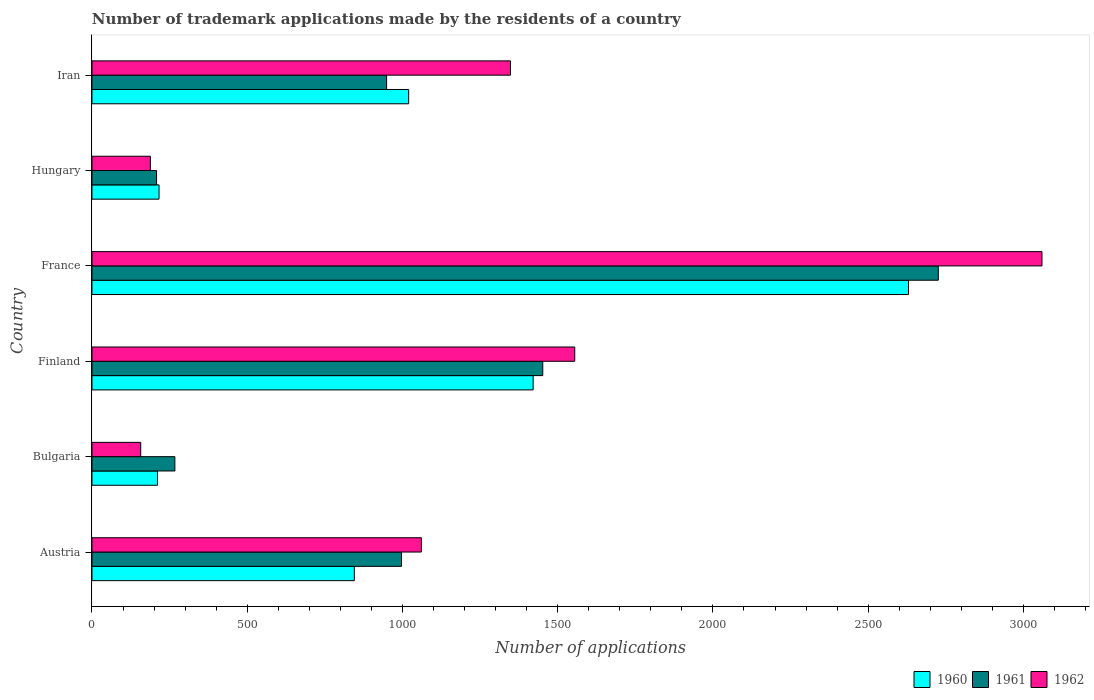How many bars are there on the 2nd tick from the top?
Ensure brevity in your answer.  3. How many bars are there on the 4th tick from the bottom?
Provide a succinct answer. 3. What is the label of the 1st group of bars from the top?
Provide a succinct answer. Iran. In how many cases, is the number of bars for a given country not equal to the number of legend labels?
Give a very brief answer. 0. What is the number of trademark applications made by the residents in 1962 in Iran?
Your answer should be compact. 1348. Across all countries, what is the maximum number of trademark applications made by the residents in 1961?
Provide a succinct answer. 2726. Across all countries, what is the minimum number of trademark applications made by the residents in 1961?
Provide a succinct answer. 208. What is the total number of trademark applications made by the residents in 1960 in the graph?
Offer a very short reply. 6343. What is the difference between the number of trademark applications made by the residents in 1960 in Austria and that in Bulgaria?
Your answer should be compact. 634. What is the difference between the number of trademark applications made by the residents in 1962 in Bulgaria and the number of trademark applications made by the residents in 1960 in Austria?
Offer a very short reply. -688. What is the average number of trademark applications made by the residents in 1962 per country?
Provide a short and direct response. 1228.17. What is the difference between the number of trademark applications made by the residents in 1962 and number of trademark applications made by the residents in 1961 in Finland?
Give a very brief answer. 103. What is the ratio of the number of trademark applications made by the residents in 1962 in Bulgaria to that in Hungary?
Offer a terse response. 0.84. What is the difference between the highest and the second highest number of trademark applications made by the residents in 1961?
Give a very brief answer. 1274. What is the difference between the highest and the lowest number of trademark applications made by the residents in 1961?
Give a very brief answer. 2518. What does the 1st bar from the bottom in Hungary represents?
Offer a very short reply. 1960. Is it the case that in every country, the sum of the number of trademark applications made by the residents in 1960 and number of trademark applications made by the residents in 1961 is greater than the number of trademark applications made by the residents in 1962?
Ensure brevity in your answer.  Yes. What is the difference between two consecutive major ticks on the X-axis?
Keep it short and to the point. 500. Are the values on the major ticks of X-axis written in scientific E-notation?
Your response must be concise. No. Does the graph contain any zero values?
Make the answer very short. No. Does the graph contain grids?
Give a very brief answer. No. How many legend labels are there?
Provide a short and direct response. 3. How are the legend labels stacked?
Make the answer very short. Horizontal. What is the title of the graph?
Ensure brevity in your answer.  Number of trademark applications made by the residents of a country. Does "2006" appear as one of the legend labels in the graph?
Offer a terse response. No. What is the label or title of the X-axis?
Provide a short and direct response. Number of applications. What is the label or title of the Y-axis?
Provide a succinct answer. Country. What is the Number of applications in 1960 in Austria?
Keep it short and to the point. 845. What is the Number of applications in 1961 in Austria?
Your response must be concise. 997. What is the Number of applications in 1962 in Austria?
Give a very brief answer. 1061. What is the Number of applications of 1960 in Bulgaria?
Offer a terse response. 211. What is the Number of applications of 1961 in Bulgaria?
Give a very brief answer. 267. What is the Number of applications in 1962 in Bulgaria?
Your answer should be compact. 157. What is the Number of applications of 1960 in Finland?
Give a very brief answer. 1421. What is the Number of applications in 1961 in Finland?
Your response must be concise. 1452. What is the Number of applications of 1962 in Finland?
Offer a terse response. 1555. What is the Number of applications of 1960 in France?
Your response must be concise. 2630. What is the Number of applications in 1961 in France?
Offer a very short reply. 2726. What is the Number of applications in 1962 in France?
Make the answer very short. 3060. What is the Number of applications in 1960 in Hungary?
Offer a very short reply. 216. What is the Number of applications of 1961 in Hungary?
Provide a succinct answer. 208. What is the Number of applications of 1962 in Hungary?
Your response must be concise. 188. What is the Number of applications in 1960 in Iran?
Ensure brevity in your answer.  1020. What is the Number of applications of 1961 in Iran?
Provide a short and direct response. 949. What is the Number of applications of 1962 in Iran?
Ensure brevity in your answer.  1348. Across all countries, what is the maximum Number of applications in 1960?
Provide a short and direct response. 2630. Across all countries, what is the maximum Number of applications of 1961?
Keep it short and to the point. 2726. Across all countries, what is the maximum Number of applications of 1962?
Provide a short and direct response. 3060. Across all countries, what is the minimum Number of applications of 1960?
Provide a short and direct response. 211. Across all countries, what is the minimum Number of applications in 1961?
Give a very brief answer. 208. Across all countries, what is the minimum Number of applications in 1962?
Provide a short and direct response. 157. What is the total Number of applications in 1960 in the graph?
Your answer should be very brief. 6343. What is the total Number of applications in 1961 in the graph?
Your answer should be very brief. 6599. What is the total Number of applications in 1962 in the graph?
Provide a succinct answer. 7369. What is the difference between the Number of applications of 1960 in Austria and that in Bulgaria?
Your answer should be compact. 634. What is the difference between the Number of applications in 1961 in Austria and that in Bulgaria?
Keep it short and to the point. 730. What is the difference between the Number of applications of 1962 in Austria and that in Bulgaria?
Your response must be concise. 904. What is the difference between the Number of applications in 1960 in Austria and that in Finland?
Ensure brevity in your answer.  -576. What is the difference between the Number of applications of 1961 in Austria and that in Finland?
Make the answer very short. -455. What is the difference between the Number of applications of 1962 in Austria and that in Finland?
Provide a short and direct response. -494. What is the difference between the Number of applications in 1960 in Austria and that in France?
Your answer should be compact. -1785. What is the difference between the Number of applications of 1961 in Austria and that in France?
Ensure brevity in your answer.  -1729. What is the difference between the Number of applications in 1962 in Austria and that in France?
Give a very brief answer. -1999. What is the difference between the Number of applications of 1960 in Austria and that in Hungary?
Offer a terse response. 629. What is the difference between the Number of applications of 1961 in Austria and that in Hungary?
Keep it short and to the point. 789. What is the difference between the Number of applications in 1962 in Austria and that in Hungary?
Your response must be concise. 873. What is the difference between the Number of applications in 1960 in Austria and that in Iran?
Your answer should be compact. -175. What is the difference between the Number of applications in 1961 in Austria and that in Iran?
Keep it short and to the point. 48. What is the difference between the Number of applications in 1962 in Austria and that in Iran?
Your response must be concise. -287. What is the difference between the Number of applications in 1960 in Bulgaria and that in Finland?
Provide a short and direct response. -1210. What is the difference between the Number of applications of 1961 in Bulgaria and that in Finland?
Provide a short and direct response. -1185. What is the difference between the Number of applications of 1962 in Bulgaria and that in Finland?
Make the answer very short. -1398. What is the difference between the Number of applications of 1960 in Bulgaria and that in France?
Provide a short and direct response. -2419. What is the difference between the Number of applications in 1961 in Bulgaria and that in France?
Ensure brevity in your answer.  -2459. What is the difference between the Number of applications in 1962 in Bulgaria and that in France?
Your response must be concise. -2903. What is the difference between the Number of applications of 1960 in Bulgaria and that in Hungary?
Ensure brevity in your answer.  -5. What is the difference between the Number of applications in 1961 in Bulgaria and that in Hungary?
Make the answer very short. 59. What is the difference between the Number of applications in 1962 in Bulgaria and that in Hungary?
Your answer should be very brief. -31. What is the difference between the Number of applications in 1960 in Bulgaria and that in Iran?
Ensure brevity in your answer.  -809. What is the difference between the Number of applications of 1961 in Bulgaria and that in Iran?
Keep it short and to the point. -682. What is the difference between the Number of applications of 1962 in Bulgaria and that in Iran?
Ensure brevity in your answer.  -1191. What is the difference between the Number of applications of 1960 in Finland and that in France?
Keep it short and to the point. -1209. What is the difference between the Number of applications of 1961 in Finland and that in France?
Offer a terse response. -1274. What is the difference between the Number of applications of 1962 in Finland and that in France?
Offer a very short reply. -1505. What is the difference between the Number of applications of 1960 in Finland and that in Hungary?
Your answer should be very brief. 1205. What is the difference between the Number of applications of 1961 in Finland and that in Hungary?
Your response must be concise. 1244. What is the difference between the Number of applications in 1962 in Finland and that in Hungary?
Give a very brief answer. 1367. What is the difference between the Number of applications in 1960 in Finland and that in Iran?
Your answer should be very brief. 401. What is the difference between the Number of applications of 1961 in Finland and that in Iran?
Give a very brief answer. 503. What is the difference between the Number of applications of 1962 in Finland and that in Iran?
Give a very brief answer. 207. What is the difference between the Number of applications in 1960 in France and that in Hungary?
Provide a short and direct response. 2414. What is the difference between the Number of applications of 1961 in France and that in Hungary?
Ensure brevity in your answer.  2518. What is the difference between the Number of applications in 1962 in France and that in Hungary?
Ensure brevity in your answer.  2872. What is the difference between the Number of applications in 1960 in France and that in Iran?
Provide a succinct answer. 1610. What is the difference between the Number of applications of 1961 in France and that in Iran?
Ensure brevity in your answer.  1777. What is the difference between the Number of applications in 1962 in France and that in Iran?
Keep it short and to the point. 1712. What is the difference between the Number of applications in 1960 in Hungary and that in Iran?
Your response must be concise. -804. What is the difference between the Number of applications of 1961 in Hungary and that in Iran?
Give a very brief answer. -741. What is the difference between the Number of applications in 1962 in Hungary and that in Iran?
Give a very brief answer. -1160. What is the difference between the Number of applications of 1960 in Austria and the Number of applications of 1961 in Bulgaria?
Give a very brief answer. 578. What is the difference between the Number of applications in 1960 in Austria and the Number of applications in 1962 in Bulgaria?
Provide a succinct answer. 688. What is the difference between the Number of applications in 1961 in Austria and the Number of applications in 1962 in Bulgaria?
Your answer should be very brief. 840. What is the difference between the Number of applications of 1960 in Austria and the Number of applications of 1961 in Finland?
Keep it short and to the point. -607. What is the difference between the Number of applications in 1960 in Austria and the Number of applications in 1962 in Finland?
Make the answer very short. -710. What is the difference between the Number of applications in 1961 in Austria and the Number of applications in 1962 in Finland?
Offer a terse response. -558. What is the difference between the Number of applications in 1960 in Austria and the Number of applications in 1961 in France?
Your answer should be very brief. -1881. What is the difference between the Number of applications in 1960 in Austria and the Number of applications in 1962 in France?
Make the answer very short. -2215. What is the difference between the Number of applications in 1961 in Austria and the Number of applications in 1962 in France?
Ensure brevity in your answer.  -2063. What is the difference between the Number of applications of 1960 in Austria and the Number of applications of 1961 in Hungary?
Offer a terse response. 637. What is the difference between the Number of applications of 1960 in Austria and the Number of applications of 1962 in Hungary?
Give a very brief answer. 657. What is the difference between the Number of applications in 1961 in Austria and the Number of applications in 1962 in Hungary?
Keep it short and to the point. 809. What is the difference between the Number of applications in 1960 in Austria and the Number of applications in 1961 in Iran?
Provide a succinct answer. -104. What is the difference between the Number of applications of 1960 in Austria and the Number of applications of 1962 in Iran?
Your answer should be compact. -503. What is the difference between the Number of applications of 1961 in Austria and the Number of applications of 1962 in Iran?
Give a very brief answer. -351. What is the difference between the Number of applications of 1960 in Bulgaria and the Number of applications of 1961 in Finland?
Provide a succinct answer. -1241. What is the difference between the Number of applications of 1960 in Bulgaria and the Number of applications of 1962 in Finland?
Your response must be concise. -1344. What is the difference between the Number of applications of 1961 in Bulgaria and the Number of applications of 1962 in Finland?
Offer a very short reply. -1288. What is the difference between the Number of applications in 1960 in Bulgaria and the Number of applications in 1961 in France?
Ensure brevity in your answer.  -2515. What is the difference between the Number of applications of 1960 in Bulgaria and the Number of applications of 1962 in France?
Offer a very short reply. -2849. What is the difference between the Number of applications of 1961 in Bulgaria and the Number of applications of 1962 in France?
Provide a succinct answer. -2793. What is the difference between the Number of applications in 1960 in Bulgaria and the Number of applications in 1961 in Hungary?
Your answer should be compact. 3. What is the difference between the Number of applications in 1960 in Bulgaria and the Number of applications in 1962 in Hungary?
Ensure brevity in your answer.  23. What is the difference between the Number of applications in 1961 in Bulgaria and the Number of applications in 1962 in Hungary?
Your answer should be very brief. 79. What is the difference between the Number of applications of 1960 in Bulgaria and the Number of applications of 1961 in Iran?
Offer a terse response. -738. What is the difference between the Number of applications of 1960 in Bulgaria and the Number of applications of 1962 in Iran?
Provide a short and direct response. -1137. What is the difference between the Number of applications of 1961 in Bulgaria and the Number of applications of 1962 in Iran?
Keep it short and to the point. -1081. What is the difference between the Number of applications of 1960 in Finland and the Number of applications of 1961 in France?
Your answer should be compact. -1305. What is the difference between the Number of applications of 1960 in Finland and the Number of applications of 1962 in France?
Offer a very short reply. -1639. What is the difference between the Number of applications of 1961 in Finland and the Number of applications of 1962 in France?
Provide a succinct answer. -1608. What is the difference between the Number of applications of 1960 in Finland and the Number of applications of 1961 in Hungary?
Your response must be concise. 1213. What is the difference between the Number of applications of 1960 in Finland and the Number of applications of 1962 in Hungary?
Offer a terse response. 1233. What is the difference between the Number of applications in 1961 in Finland and the Number of applications in 1962 in Hungary?
Your answer should be compact. 1264. What is the difference between the Number of applications of 1960 in Finland and the Number of applications of 1961 in Iran?
Offer a terse response. 472. What is the difference between the Number of applications of 1960 in Finland and the Number of applications of 1962 in Iran?
Offer a terse response. 73. What is the difference between the Number of applications in 1961 in Finland and the Number of applications in 1962 in Iran?
Offer a terse response. 104. What is the difference between the Number of applications of 1960 in France and the Number of applications of 1961 in Hungary?
Provide a succinct answer. 2422. What is the difference between the Number of applications in 1960 in France and the Number of applications in 1962 in Hungary?
Keep it short and to the point. 2442. What is the difference between the Number of applications of 1961 in France and the Number of applications of 1962 in Hungary?
Give a very brief answer. 2538. What is the difference between the Number of applications in 1960 in France and the Number of applications in 1961 in Iran?
Provide a succinct answer. 1681. What is the difference between the Number of applications in 1960 in France and the Number of applications in 1962 in Iran?
Your answer should be very brief. 1282. What is the difference between the Number of applications in 1961 in France and the Number of applications in 1962 in Iran?
Make the answer very short. 1378. What is the difference between the Number of applications of 1960 in Hungary and the Number of applications of 1961 in Iran?
Offer a very short reply. -733. What is the difference between the Number of applications of 1960 in Hungary and the Number of applications of 1962 in Iran?
Offer a very short reply. -1132. What is the difference between the Number of applications in 1961 in Hungary and the Number of applications in 1962 in Iran?
Offer a very short reply. -1140. What is the average Number of applications in 1960 per country?
Make the answer very short. 1057.17. What is the average Number of applications in 1961 per country?
Make the answer very short. 1099.83. What is the average Number of applications in 1962 per country?
Ensure brevity in your answer.  1228.17. What is the difference between the Number of applications in 1960 and Number of applications in 1961 in Austria?
Offer a very short reply. -152. What is the difference between the Number of applications in 1960 and Number of applications in 1962 in Austria?
Give a very brief answer. -216. What is the difference between the Number of applications of 1961 and Number of applications of 1962 in Austria?
Your response must be concise. -64. What is the difference between the Number of applications of 1960 and Number of applications of 1961 in Bulgaria?
Keep it short and to the point. -56. What is the difference between the Number of applications of 1961 and Number of applications of 1962 in Bulgaria?
Offer a very short reply. 110. What is the difference between the Number of applications in 1960 and Number of applications in 1961 in Finland?
Give a very brief answer. -31. What is the difference between the Number of applications of 1960 and Number of applications of 1962 in Finland?
Your answer should be very brief. -134. What is the difference between the Number of applications of 1961 and Number of applications of 1962 in Finland?
Keep it short and to the point. -103. What is the difference between the Number of applications in 1960 and Number of applications in 1961 in France?
Your answer should be very brief. -96. What is the difference between the Number of applications in 1960 and Number of applications in 1962 in France?
Your response must be concise. -430. What is the difference between the Number of applications in 1961 and Number of applications in 1962 in France?
Your response must be concise. -334. What is the difference between the Number of applications of 1961 and Number of applications of 1962 in Hungary?
Your answer should be very brief. 20. What is the difference between the Number of applications of 1960 and Number of applications of 1962 in Iran?
Offer a terse response. -328. What is the difference between the Number of applications of 1961 and Number of applications of 1962 in Iran?
Give a very brief answer. -399. What is the ratio of the Number of applications in 1960 in Austria to that in Bulgaria?
Provide a succinct answer. 4. What is the ratio of the Number of applications of 1961 in Austria to that in Bulgaria?
Give a very brief answer. 3.73. What is the ratio of the Number of applications of 1962 in Austria to that in Bulgaria?
Ensure brevity in your answer.  6.76. What is the ratio of the Number of applications in 1960 in Austria to that in Finland?
Keep it short and to the point. 0.59. What is the ratio of the Number of applications of 1961 in Austria to that in Finland?
Keep it short and to the point. 0.69. What is the ratio of the Number of applications in 1962 in Austria to that in Finland?
Keep it short and to the point. 0.68. What is the ratio of the Number of applications of 1960 in Austria to that in France?
Ensure brevity in your answer.  0.32. What is the ratio of the Number of applications of 1961 in Austria to that in France?
Ensure brevity in your answer.  0.37. What is the ratio of the Number of applications of 1962 in Austria to that in France?
Offer a terse response. 0.35. What is the ratio of the Number of applications of 1960 in Austria to that in Hungary?
Your answer should be very brief. 3.91. What is the ratio of the Number of applications of 1961 in Austria to that in Hungary?
Give a very brief answer. 4.79. What is the ratio of the Number of applications in 1962 in Austria to that in Hungary?
Offer a terse response. 5.64. What is the ratio of the Number of applications of 1960 in Austria to that in Iran?
Make the answer very short. 0.83. What is the ratio of the Number of applications in 1961 in Austria to that in Iran?
Keep it short and to the point. 1.05. What is the ratio of the Number of applications in 1962 in Austria to that in Iran?
Your answer should be very brief. 0.79. What is the ratio of the Number of applications in 1960 in Bulgaria to that in Finland?
Make the answer very short. 0.15. What is the ratio of the Number of applications of 1961 in Bulgaria to that in Finland?
Your answer should be compact. 0.18. What is the ratio of the Number of applications in 1962 in Bulgaria to that in Finland?
Provide a succinct answer. 0.1. What is the ratio of the Number of applications of 1960 in Bulgaria to that in France?
Offer a very short reply. 0.08. What is the ratio of the Number of applications of 1961 in Bulgaria to that in France?
Keep it short and to the point. 0.1. What is the ratio of the Number of applications of 1962 in Bulgaria to that in France?
Offer a very short reply. 0.05. What is the ratio of the Number of applications in 1960 in Bulgaria to that in Hungary?
Offer a terse response. 0.98. What is the ratio of the Number of applications in 1961 in Bulgaria to that in Hungary?
Provide a short and direct response. 1.28. What is the ratio of the Number of applications of 1962 in Bulgaria to that in Hungary?
Provide a short and direct response. 0.84. What is the ratio of the Number of applications in 1960 in Bulgaria to that in Iran?
Your answer should be very brief. 0.21. What is the ratio of the Number of applications in 1961 in Bulgaria to that in Iran?
Give a very brief answer. 0.28. What is the ratio of the Number of applications of 1962 in Bulgaria to that in Iran?
Offer a very short reply. 0.12. What is the ratio of the Number of applications in 1960 in Finland to that in France?
Offer a terse response. 0.54. What is the ratio of the Number of applications in 1961 in Finland to that in France?
Your response must be concise. 0.53. What is the ratio of the Number of applications in 1962 in Finland to that in France?
Make the answer very short. 0.51. What is the ratio of the Number of applications in 1960 in Finland to that in Hungary?
Keep it short and to the point. 6.58. What is the ratio of the Number of applications in 1961 in Finland to that in Hungary?
Provide a short and direct response. 6.98. What is the ratio of the Number of applications of 1962 in Finland to that in Hungary?
Provide a short and direct response. 8.27. What is the ratio of the Number of applications in 1960 in Finland to that in Iran?
Keep it short and to the point. 1.39. What is the ratio of the Number of applications in 1961 in Finland to that in Iran?
Your response must be concise. 1.53. What is the ratio of the Number of applications in 1962 in Finland to that in Iran?
Offer a very short reply. 1.15. What is the ratio of the Number of applications in 1960 in France to that in Hungary?
Ensure brevity in your answer.  12.18. What is the ratio of the Number of applications of 1961 in France to that in Hungary?
Give a very brief answer. 13.11. What is the ratio of the Number of applications in 1962 in France to that in Hungary?
Your response must be concise. 16.28. What is the ratio of the Number of applications in 1960 in France to that in Iran?
Keep it short and to the point. 2.58. What is the ratio of the Number of applications of 1961 in France to that in Iran?
Ensure brevity in your answer.  2.87. What is the ratio of the Number of applications in 1962 in France to that in Iran?
Offer a terse response. 2.27. What is the ratio of the Number of applications of 1960 in Hungary to that in Iran?
Your answer should be very brief. 0.21. What is the ratio of the Number of applications of 1961 in Hungary to that in Iran?
Provide a short and direct response. 0.22. What is the ratio of the Number of applications in 1962 in Hungary to that in Iran?
Your response must be concise. 0.14. What is the difference between the highest and the second highest Number of applications of 1960?
Keep it short and to the point. 1209. What is the difference between the highest and the second highest Number of applications of 1961?
Make the answer very short. 1274. What is the difference between the highest and the second highest Number of applications in 1962?
Your response must be concise. 1505. What is the difference between the highest and the lowest Number of applications of 1960?
Offer a very short reply. 2419. What is the difference between the highest and the lowest Number of applications in 1961?
Provide a succinct answer. 2518. What is the difference between the highest and the lowest Number of applications of 1962?
Ensure brevity in your answer.  2903. 